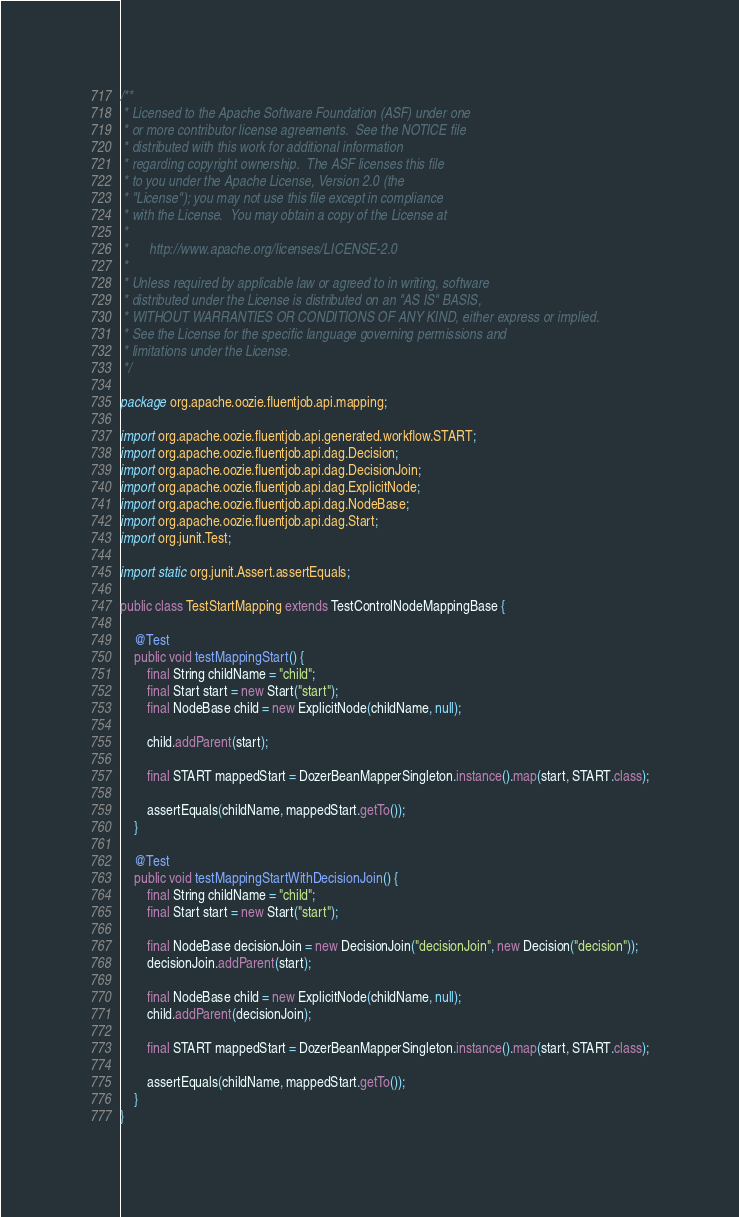<code> <loc_0><loc_0><loc_500><loc_500><_Java_>/**
 * Licensed to the Apache Software Foundation (ASF) under one
 * or more contributor license agreements.  See the NOTICE file
 * distributed with this work for additional information
 * regarding copyright ownership.  The ASF licenses this file
 * to you under the Apache License, Version 2.0 (the
 * "License"); you may not use this file except in compliance
 * with the License.  You may obtain a copy of the License at
 *
 *      http://www.apache.org/licenses/LICENSE-2.0
 *
 * Unless required by applicable law or agreed to in writing, software
 * distributed under the License is distributed on an "AS IS" BASIS,
 * WITHOUT WARRANTIES OR CONDITIONS OF ANY KIND, either express or implied.
 * See the License for the specific language governing permissions and
 * limitations under the License.
 */

package org.apache.oozie.fluentjob.api.mapping;

import org.apache.oozie.fluentjob.api.generated.workflow.START;
import org.apache.oozie.fluentjob.api.dag.Decision;
import org.apache.oozie.fluentjob.api.dag.DecisionJoin;
import org.apache.oozie.fluentjob.api.dag.ExplicitNode;
import org.apache.oozie.fluentjob.api.dag.NodeBase;
import org.apache.oozie.fluentjob.api.dag.Start;
import org.junit.Test;

import static org.junit.Assert.assertEquals;

public class TestStartMapping extends TestControlNodeMappingBase {

    @Test
    public void testMappingStart() {
        final String childName = "child";
        final Start start = new Start("start");
        final NodeBase child = new ExplicitNode(childName, null);

        child.addParent(start);

        final START mappedStart = DozerBeanMapperSingleton.instance().map(start, START.class);

        assertEquals(childName, mappedStart.getTo());
    }

    @Test
    public void testMappingStartWithDecisionJoin() {
        final String childName = "child";
        final Start start = new Start("start");

        final NodeBase decisionJoin = new DecisionJoin("decisionJoin", new Decision("decision"));
        decisionJoin.addParent(start);

        final NodeBase child = new ExplicitNode(childName, null);
        child.addParent(decisionJoin);

        final START mappedStart = DozerBeanMapperSingleton.instance().map(start, START.class);

        assertEquals(childName, mappedStart.getTo());
    }
}
</code> 